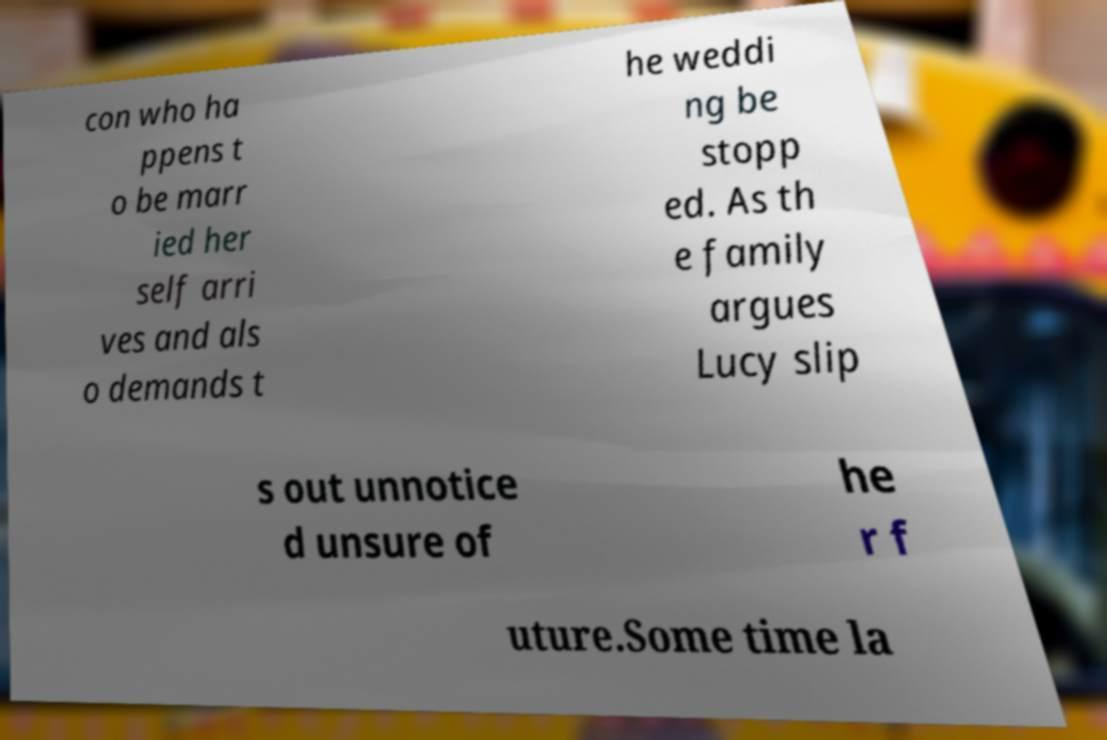Please read and relay the text visible in this image. What does it say? con who ha ppens t o be marr ied her self arri ves and als o demands t he weddi ng be stopp ed. As th e family argues Lucy slip s out unnotice d unsure of he r f uture.Some time la 